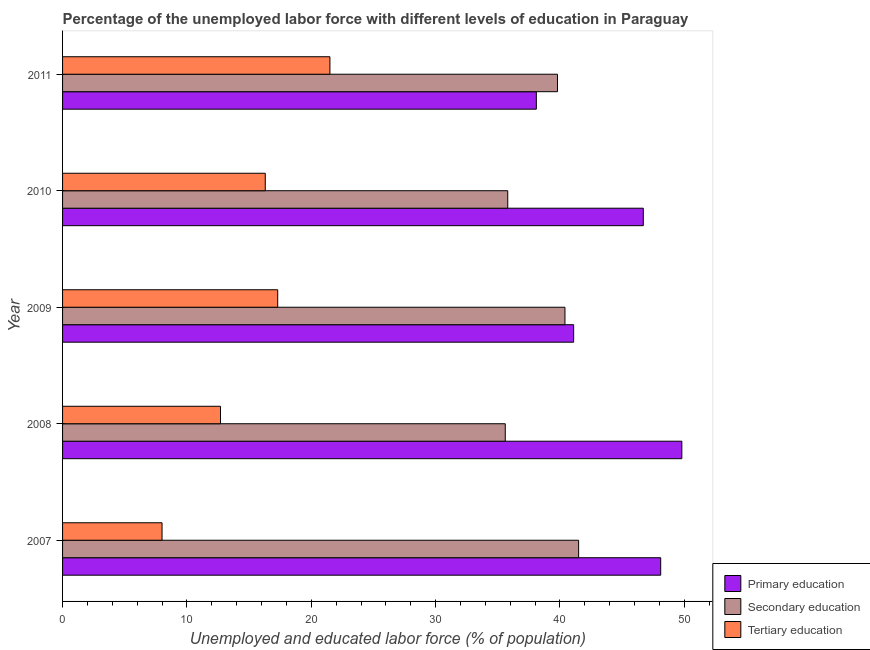How many groups of bars are there?
Offer a very short reply. 5. Are the number of bars on each tick of the Y-axis equal?
Your answer should be very brief. Yes. How many bars are there on the 3rd tick from the top?
Provide a succinct answer. 3. What is the label of the 3rd group of bars from the top?
Your answer should be very brief. 2009. What is the percentage of labor force who received primary education in 2007?
Ensure brevity in your answer.  48.1. Across all years, what is the minimum percentage of labor force who received primary education?
Provide a succinct answer. 38.1. In which year was the percentage of labor force who received primary education maximum?
Ensure brevity in your answer.  2008. What is the total percentage of labor force who received secondary education in the graph?
Provide a succinct answer. 193.1. What is the difference between the percentage of labor force who received primary education in 2007 and that in 2009?
Provide a short and direct response. 7. What is the difference between the percentage of labor force who received tertiary education in 2008 and the percentage of labor force who received secondary education in 2009?
Make the answer very short. -27.7. What is the average percentage of labor force who received secondary education per year?
Offer a very short reply. 38.62. In the year 2009, what is the difference between the percentage of labor force who received tertiary education and percentage of labor force who received secondary education?
Your answer should be very brief. -23.1. In how many years, is the percentage of labor force who received primary education greater than 4 %?
Offer a very short reply. 5. What is the ratio of the percentage of labor force who received tertiary education in 2008 to that in 2011?
Give a very brief answer. 0.59. Is the percentage of labor force who received primary education in 2009 less than that in 2010?
Your answer should be very brief. Yes. Is the difference between the percentage of labor force who received tertiary education in 2010 and 2011 greater than the difference between the percentage of labor force who received primary education in 2010 and 2011?
Ensure brevity in your answer.  No. What is the difference between the highest and the second highest percentage of labor force who received secondary education?
Provide a short and direct response. 1.1. What is the difference between the highest and the lowest percentage of labor force who received tertiary education?
Keep it short and to the point. 13.5. What does the 1st bar from the top in 2009 represents?
Offer a terse response. Tertiary education. What does the 3rd bar from the bottom in 2009 represents?
Make the answer very short. Tertiary education. Are all the bars in the graph horizontal?
Offer a terse response. Yes. How many years are there in the graph?
Offer a terse response. 5. What is the difference between two consecutive major ticks on the X-axis?
Your response must be concise. 10. Where does the legend appear in the graph?
Keep it short and to the point. Bottom right. How many legend labels are there?
Your answer should be compact. 3. How are the legend labels stacked?
Offer a terse response. Vertical. What is the title of the graph?
Provide a short and direct response. Percentage of the unemployed labor force with different levels of education in Paraguay. Does "Tertiary education" appear as one of the legend labels in the graph?
Offer a very short reply. Yes. What is the label or title of the X-axis?
Provide a succinct answer. Unemployed and educated labor force (% of population). What is the label or title of the Y-axis?
Provide a succinct answer. Year. What is the Unemployed and educated labor force (% of population) of Primary education in 2007?
Your answer should be very brief. 48.1. What is the Unemployed and educated labor force (% of population) in Secondary education in 2007?
Offer a very short reply. 41.5. What is the Unemployed and educated labor force (% of population) of Tertiary education in 2007?
Offer a terse response. 8. What is the Unemployed and educated labor force (% of population) of Primary education in 2008?
Your answer should be compact. 49.8. What is the Unemployed and educated labor force (% of population) in Secondary education in 2008?
Give a very brief answer. 35.6. What is the Unemployed and educated labor force (% of population) of Tertiary education in 2008?
Your response must be concise. 12.7. What is the Unemployed and educated labor force (% of population) of Primary education in 2009?
Offer a terse response. 41.1. What is the Unemployed and educated labor force (% of population) in Secondary education in 2009?
Ensure brevity in your answer.  40.4. What is the Unemployed and educated labor force (% of population) in Tertiary education in 2009?
Provide a succinct answer. 17.3. What is the Unemployed and educated labor force (% of population) in Primary education in 2010?
Offer a terse response. 46.7. What is the Unemployed and educated labor force (% of population) in Secondary education in 2010?
Your answer should be compact. 35.8. What is the Unemployed and educated labor force (% of population) of Tertiary education in 2010?
Make the answer very short. 16.3. What is the Unemployed and educated labor force (% of population) of Primary education in 2011?
Give a very brief answer. 38.1. What is the Unemployed and educated labor force (% of population) of Secondary education in 2011?
Offer a terse response. 39.8. Across all years, what is the maximum Unemployed and educated labor force (% of population) of Primary education?
Provide a succinct answer. 49.8. Across all years, what is the maximum Unemployed and educated labor force (% of population) in Secondary education?
Make the answer very short. 41.5. Across all years, what is the maximum Unemployed and educated labor force (% of population) in Tertiary education?
Your response must be concise. 21.5. Across all years, what is the minimum Unemployed and educated labor force (% of population) in Primary education?
Provide a succinct answer. 38.1. Across all years, what is the minimum Unemployed and educated labor force (% of population) in Secondary education?
Make the answer very short. 35.6. Across all years, what is the minimum Unemployed and educated labor force (% of population) in Tertiary education?
Keep it short and to the point. 8. What is the total Unemployed and educated labor force (% of population) of Primary education in the graph?
Offer a terse response. 223.8. What is the total Unemployed and educated labor force (% of population) of Secondary education in the graph?
Your response must be concise. 193.1. What is the total Unemployed and educated labor force (% of population) of Tertiary education in the graph?
Make the answer very short. 75.8. What is the difference between the Unemployed and educated labor force (% of population) in Secondary education in 2007 and that in 2008?
Give a very brief answer. 5.9. What is the difference between the Unemployed and educated labor force (% of population) of Tertiary education in 2007 and that in 2008?
Your response must be concise. -4.7. What is the difference between the Unemployed and educated labor force (% of population) of Secondary education in 2007 and that in 2009?
Ensure brevity in your answer.  1.1. What is the difference between the Unemployed and educated labor force (% of population) in Primary education in 2007 and that in 2010?
Provide a succinct answer. 1.4. What is the difference between the Unemployed and educated labor force (% of population) in Primary education in 2007 and that in 2011?
Offer a very short reply. 10. What is the difference between the Unemployed and educated labor force (% of population) of Secondary education in 2007 and that in 2011?
Your response must be concise. 1.7. What is the difference between the Unemployed and educated labor force (% of population) of Tertiary education in 2007 and that in 2011?
Your answer should be compact. -13.5. What is the difference between the Unemployed and educated labor force (% of population) in Secondary education in 2008 and that in 2009?
Provide a succinct answer. -4.8. What is the difference between the Unemployed and educated labor force (% of population) of Primary education in 2008 and that in 2010?
Offer a terse response. 3.1. What is the difference between the Unemployed and educated labor force (% of population) in Secondary education in 2008 and that in 2010?
Keep it short and to the point. -0.2. What is the difference between the Unemployed and educated labor force (% of population) in Tertiary education in 2008 and that in 2010?
Your answer should be compact. -3.6. What is the difference between the Unemployed and educated labor force (% of population) of Primary education in 2008 and that in 2011?
Ensure brevity in your answer.  11.7. What is the difference between the Unemployed and educated labor force (% of population) of Tertiary education in 2009 and that in 2010?
Give a very brief answer. 1. What is the difference between the Unemployed and educated labor force (% of population) in Tertiary education in 2009 and that in 2011?
Your response must be concise. -4.2. What is the difference between the Unemployed and educated labor force (% of population) in Primary education in 2010 and that in 2011?
Provide a succinct answer. 8.6. What is the difference between the Unemployed and educated labor force (% of population) of Secondary education in 2010 and that in 2011?
Your answer should be compact. -4. What is the difference between the Unemployed and educated labor force (% of population) in Tertiary education in 2010 and that in 2011?
Your answer should be very brief. -5.2. What is the difference between the Unemployed and educated labor force (% of population) of Primary education in 2007 and the Unemployed and educated labor force (% of population) of Secondary education in 2008?
Offer a terse response. 12.5. What is the difference between the Unemployed and educated labor force (% of population) of Primary education in 2007 and the Unemployed and educated labor force (% of population) of Tertiary education in 2008?
Make the answer very short. 35.4. What is the difference between the Unemployed and educated labor force (% of population) of Secondary education in 2007 and the Unemployed and educated labor force (% of population) of Tertiary education in 2008?
Provide a succinct answer. 28.8. What is the difference between the Unemployed and educated labor force (% of population) of Primary education in 2007 and the Unemployed and educated labor force (% of population) of Tertiary education in 2009?
Provide a succinct answer. 30.8. What is the difference between the Unemployed and educated labor force (% of population) in Secondary education in 2007 and the Unemployed and educated labor force (% of population) in Tertiary education in 2009?
Ensure brevity in your answer.  24.2. What is the difference between the Unemployed and educated labor force (% of population) in Primary education in 2007 and the Unemployed and educated labor force (% of population) in Tertiary education in 2010?
Your answer should be very brief. 31.8. What is the difference between the Unemployed and educated labor force (% of population) of Secondary education in 2007 and the Unemployed and educated labor force (% of population) of Tertiary education in 2010?
Offer a very short reply. 25.2. What is the difference between the Unemployed and educated labor force (% of population) in Primary education in 2007 and the Unemployed and educated labor force (% of population) in Secondary education in 2011?
Keep it short and to the point. 8.3. What is the difference between the Unemployed and educated labor force (% of population) of Primary education in 2007 and the Unemployed and educated labor force (% of population) of Tertiary education in 2011?
Make the answer very short. 26.6. What is the difference between the Unemployed and educated labor force (% of population) in Secondary education in 2007 and the Unemployed and educated labor force (% of population) in Tertiary education in 2011?
Keep it short and to the point. 20. What is the difference between the Unemployed and educated labor force (% of population) in Primary education in 2008 and the Unemployed and educated labor force (% of population) in Tertiary education in 2009?
Your response must be concise. 32.5. What is the difference between the Unemployed and educated labor force (% of population) of Secondary education in 2008 and the Unemployed and educated labor force (% of population) of Tertiary education in 2009?
Give a very brief answer. 18.3. What is the difference between the Unemployed and educated labor force (% of population) of Primary education in 2008 and the Unemployed and educated labor force (% of population) of Tertiary education in 2010?
Your answer should be very brief. 33.5. What is the difference between the Unemployed and educated labor force (% of population) of Secondary education in 2008 and the Unemployed and educated labor force (% of population) of Tertiary education in 2010?
Offer a very short reply. 19.3. What is the difference between the Unemployed and educated labor force (% of population) of Primary education in 2008 and the Unemployed and educated labor force (% of population) of Secondary education in 2011?
Your answer should be compact. 10. What is the difference between the Unemployed and educated labor force (% of population) in Primary education in 2008 and the Unemployed and educated labor force (% of population) in Tertiary education in 2011?
Offer a very short reply. 28.3. What is the difference between the Unemployed and educated labor force (% of population) in Secondary education in 2008 and the Unemployed and educated labor force (% of population) in Tertiary education in 2011?
Keep it short and to the point. 14.1. What is the difference between the Unemployed and educated labor force (% of population) of Primary education in 2009 and the Unemployed and educated labor force (% of population) of Tertiary education in 2010?
Offer a terse response. 24.8. What is the difference between the Unemployed and educated labor force (% of population) in Secondary education in 2009 and the Unemployed and educated labor force (% of population) in Tertiary education in 2010?
Make the answer very short. 24.1. What is the difference between the Unemployed and educated labor force (% of population) of Primary education in 2009 and the Unemployed and educated labor force (% of population) of Tertiary education in 2011?
Your answer should be very brief. 19.6. What is the difference between the Unemployed and educated labor force (% of population) of Primary education in 2010 and the Unemployed and educated labor force (% of population) of Tertiary education in 2011?
Provide a succinct answer. 25.2. What is the average Unemployed and educated labor force (% of population) in Primary education per year?
Make the answer very short. 44.76. What is the average Unemployed and educated labor force (% of population) in Secondary education per year?
Provide a succinct answer. 38.62. What is the average Unemployed and educated labor force (% of population) of Tertiary education per year?
Your response must be concise. 15.16. In the year 2007, what is the difference between the Unemployed and educated labor force (% of population) in Primary education and Unemployed and educated labor force (% of population) in Secondary education?
Your answer should be compact. 6.6. In the year 2007, what is the difference between the Unemployed and educated labor force (% of population) in Primary education and Unemployed and educated labor force (% of population) in Tertiary education?
Provide a succinct answer. 40.1. In the year 2007, what is the difference between the Unemployed and educated labor force (% of population) in Secondary education and Unemployed and educated labor force (% of population) in Tertiary education?
Provide a short and direct response. 33.5. In the year 2008, what is the difference between the Unemployed and educated labor force (% of population) of Primary education and Unemployed and educated labor force (% of population) of Secondary education?
Offer a very short reply. 14.2. In the year 2008, what is the difference between the Unemployed and educated labor force (% of population) of Primary education and Unemployed and educated labor force (% of population) of Tertiary education?
Offer a very short reply. 37.1. In the year 2008, what is the difference between the Unemployed and educated labor force (% of population) in Secondary education and Unemployed and educated labor force (% of population) in Tertiary education?
Keep it short and to the point. 22.9. In the year 2009, what is the difference between the Unemployed and educated labor force (% of population) in Primary education and Unemployed and educated labor force (% of population) in Tertiary education?
Ensure brevity in your answer.  23.8. In the year 2009, what is the difference between the Unemployed and educated labor force (% of population) in Secondary education and Unemployed and educated labor force (% of population) in Tertiary education?
Offer a very short reply. 23.1. In the year 2010, what is the difference between the Unemployed and educated labor force (% of population) in Primary education and Unemployed and educated labor force (% of population) in Tertiary education?
Offer a very short reply. 30.4. In the year 2011, what is the difference between the Unemployed and educated labor force (% of population) in Primary education and Unemployed and educated labor force (% of population) in Secondary education?
Your response must be concise. -1.7. In the year 2011, what is the difference between the Unemployed and educated labor force (% of population) in Primary education and Unemployed and educated labor force (% of population) in Tertiary education?
Provide a succinct answer. 16.6. In the year 2011, what is the difference between the Unemployed and educated labor force (% of population) in Secondary education and Unemployed and educated labor force (% of population) in Tertiary education?
Ensure brevity in your answer.  18.3. What is the ratio of the Unemployed and educated labor force (% of population) in Primary education in 2007 to that in 2008?
Your answer should be very brief. 0.97. What is the ratio of the Unemployed and educated labor force (% of population) of Secondary education in 2007 to that in 2008?
Provide a short and direct response. 1.17. What is the ratio of the Unemployed and educated labor force (% of population) in Tertiary education in 2007 to that in 2008?
Offer a very short reply. 0.63. What is the ratio of the Unemployed and educated labor force (% of population) of Primary education in 2007 to that in 2009?
Offer a terse response. 1.17. What is the ratio of the Unemployed and educated labor force (% of population) in Secondary education in 2007 to that in 2009?
Offer a very short reply. 1.03. What is the ratio of the Unemployed and educated labor force (% of population) in Tertiary education in 2007 to that in 2009?
Your response must be concise. 0.46. What is the ratio of the Unemployed and educated labor force (% of population) of Primary education in 2007 to that in 2010?
Make the answer very short. 1.03. What is the ratio of the Unemployed and educated labor force (% of population) of Secondary education in 2007 to that in 2010?
Provide a short and direct response. 1.16. What is the ratio of the Unemployed and educated labor force (% of population) in Tertiary education in 2007 to that in 2010?
Offer a terse response. 0.49. What is the ratio of the Unemployed and educated labor force (% of population) of Primary education in 2007 to that in 2011?
Your answer should be compact. 1.26. What is the ratio of the Unemployed and educated labor force (% of population) in Secondary education in 2007 to that in 2011?
Provide a succinct answer. 1.04. What is the ratio of the Unemployed and educated labor force (% of population) in Tertiary education in 2007 to that in 2011?
Keep it short and to the point. 0.37. What is the ratio of the Unemployed and educated labor force (% of population) in Primary education in 2008 to that in 2009?
Offer a very short reply. 1.21. What is the ratio of the Unemployed and educated labor force (% of population) of Secondary education in 2008 to that in 2009?
Give a very brief answer. 0.88. What is the ratio of the Unemployed and educated labor force (% of population) in Tertiary education in 2008 to that in 2009?
Offer a very short reply. 0.73. What is the ratio of the Unemployed and educated labor force (% of population) in Primary education in 2008 to that in 2010?
Keep it short and to the point. 1.07. What is the ratio of the Unemployed and educated labor force (% of population) in Secondary education in 2008 to that in 2010?
Ensure brevity in your answer.  0.99. What is the ratio of the Unemployed and educated labor force (% of population) of Tertiary education in 2008 to that in 2010?
Offer a very short reply. 0.78. What is the ratio of the Unemployed and educated labor force (% of population) in Primary education in 2008 to that in 2011?
Your response must be concise. 1.31. What is the ratio of the Unemployed and educated labor force (% of population) of Secondary education in 2008 to that in 2011?
Ensure brevity in your answer.  0.89. What is the ratio of the Unemployed and educated labor force (% of population) of Tertiary education in 2008 to that in 2011?
Ensure brevity in your answer.  0.59. What is the ratio of the Unemployed and educated labor force (% of population) of Primary education in 2009 to that in 2010?
Ensure brevity in your answer.  0.88. What is the ratio of the Unemployed and educated labor force (% of population) of Secondary education in 2009 to that in 2010?
Ensure brevity in your answer.  1.13. What is the ratio of the Unemployed and educated labor force (% of population) in Tertiary education in 2009 to that in 2010?
Keep it short and to the point. 1.06. What is the ratio of the Unemployed and educated labor force (% of population) in Primary education in 2009 to that in 2011?
Provide a succinct answer. 1.08. What is the ratio of the Unemployed and educated labor force (% of population) in Secondary education in 2009 to that in 2011?
Give a very brief answer. 1.02. What is the ratio of the Unemployed and educated labor force (% of population) of Tertiary education in 2009 to that in 2011?
Keep it short and to the point. 0.8. What is the ratio of the Unemployed and educated labor force (% of population) of Primary education in 2010 to that in 2011?
Ensure brevity in your answer.  1.23. What is the ratio of the Unemployed and educated labor force (% of population) in Secondary education in 2010 to that in 2011?
Make the answer very short. 0.9. What is the ratio of the Unemployed and educated labor force (% of population) of Tertiary education in 2010 to that in 2011?
Ensure brevity in your answer.  0.76. What is the difference between the highest and the second highest Unemployed and educated labor force (% of population) of Primary education?
Give a very brief answer. 1.7. What is the difference between the highest and the second highest Unemployed and educated labor force (% of population) of Secondary education?
Make the answer very short. 1.1. What is the difference between the highest and the lowest Unemployed and educated labor force (% of population) of Primary education?
Your response must be concise. 11.7. What is the difference between the highest and the lowest Unemployed and educated labor force (% of population) in Secondary education?
Offer a very short reply. 5.9. What is the difference between the highest and the lowest Unemployed and educated labor force (% of population) in Tertiary education?
Offer a terse response. 13.5. 